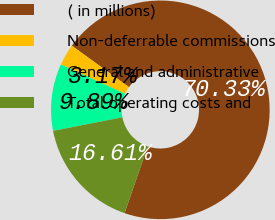Convert chart to OTSL. <chart><loc_0><loc_0><loc_500><loc_500><pie_chart><fcel>( in millions)<fcel>Non-deferrable commissions<fcel>General and administrative<fcel>Total operating costs and<nl><fcel>70.33%<fcel>3.17%<fcel>9.89%<fcel>16.61%<nl></chart> 